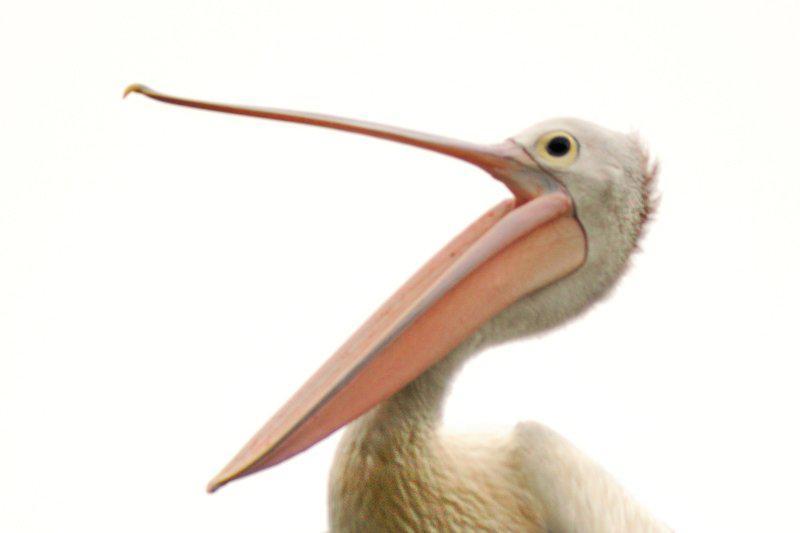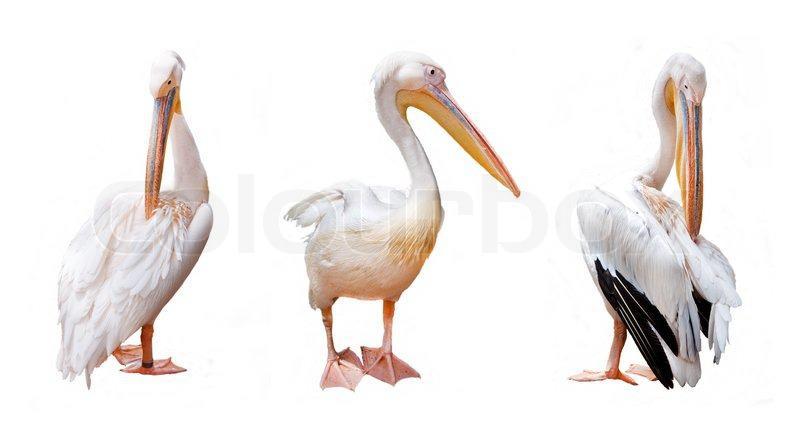The first image is the image on the left, the second image is the image on the right. Evaluate the accuracy of this statement regarding the images: "There are no more than 4 pelicans.". Is it true? Answer yes or no. Yes. The first image is the image on the left, the second image is the image on the right. Considering the images on both sides, is "AT least 2 black and white pelicans are flying to the right." valid? Answer yes or no. No. 